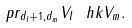Convert formula to latex. <formula><loc_0><loc_0><loc_500><loc_500>p r _ { d _ { l } + 1 , d _ { m } } V _ { l } \ h k V _ { m } .</formula> 